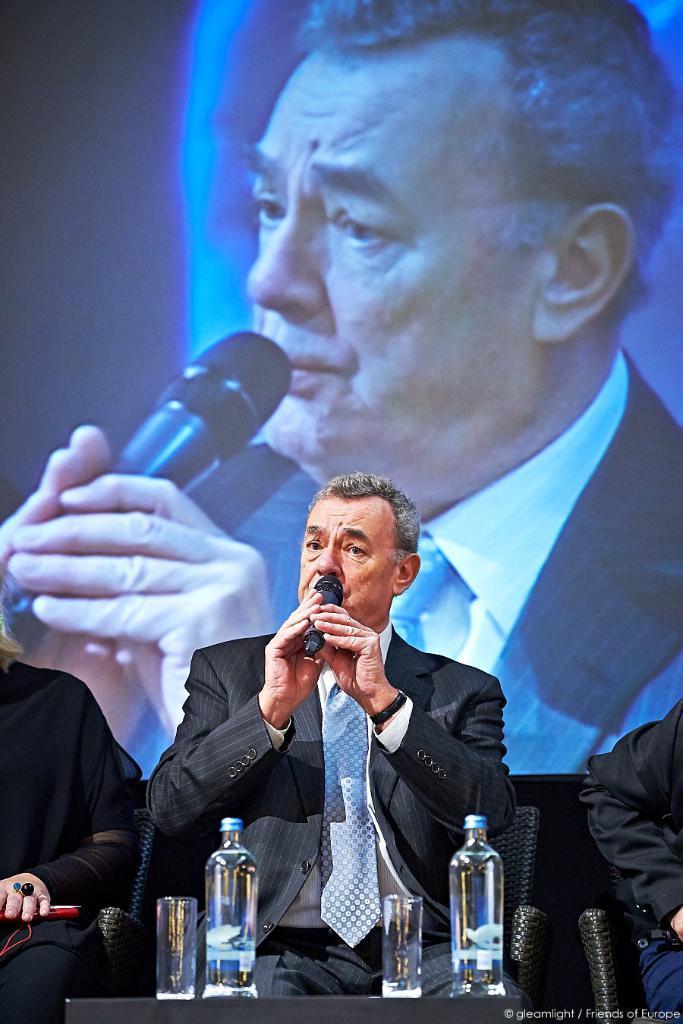Can you describe this image briefly? Here we can see that a man is sitting on the chair and holding a microphone in the hand, and in front there are water bottles and glasses on the table on it. 